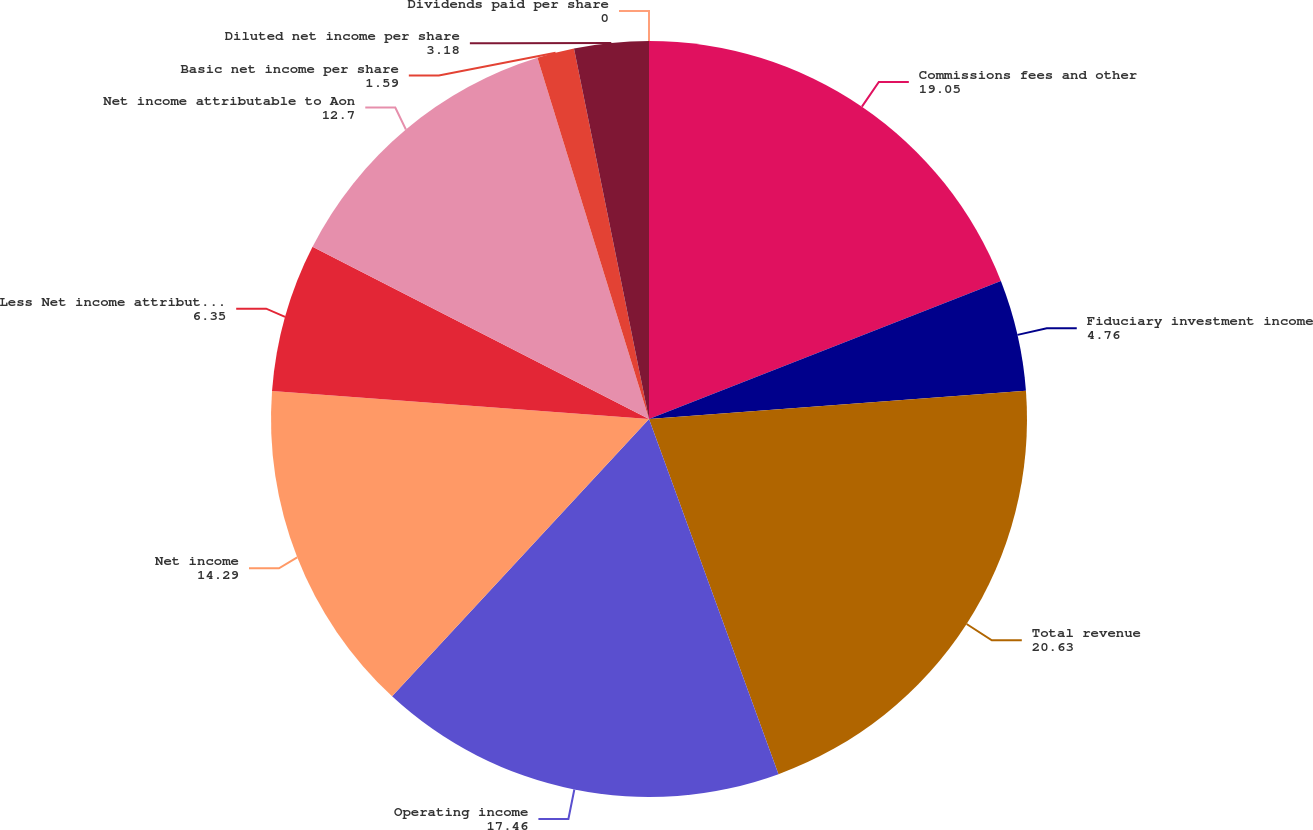Convert chart. <chart><loc_0><loc_0><loc_500><loc_500><pie_chart><fcel>Commissions fees and other<fcel>Fiduciary investment income<fcel>Total revenue<fcel>Operating income<fcel>Net income<fcel>Less Net income attributable<fcel>Net income attributable to Aon<fcel>Basic net income per share<fcel>Diluted net income per share<fcel>Dividends paid per share<nl><fcel>19.05%<fcel>4.76%<fcel>20.63%<fcel>17.46%<fcel>14.29%<fcel>6.35%<fcel>12.7%<fcel>1.59%<fcel>3.18%<fcel>0.0%<nl></chart> 